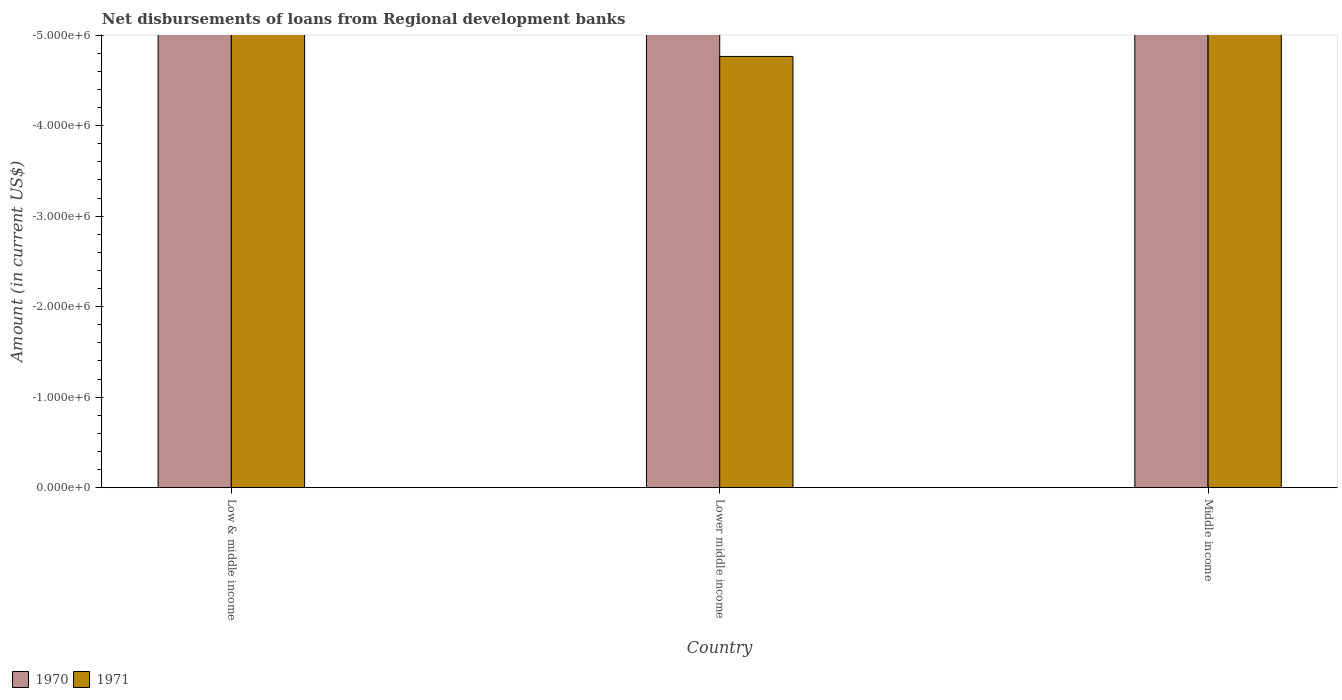How many different coloured bars are there?
Provide a short and direct response. 0. Are the number of bars per tick equal to the number of legend labels?
Provide a short and direct response. No. Are the number of bars on each tick of the X-axis equal?
Offer a very short reply. Yes. How many bars are there on the 2nd tick from the right?
Keep it short and to the point. 0. In how many cases, is the number of bars for a given country not equal to the number of legend labels?
Provide a short and direct response. 3. What is the amount of disbursements of loans from regional development banks in 1971 in Lower middle income?
Your answer should be compact. 0. What is the average amount of disbursements of loans from regional development banks in 1970 per country?
Give a very brief answer. 0. How many countries are there in the graph?
Provide a short and direct response. 3. Does the graph contain any zero values?
Provide a short and direct response. Yes. Does the graph contain grids?
Ensure brevity in your answer.  No. How many legend labels are there?
Ensure brevity in your answer.  2. What is the title of the graph?
Your answer should be very brief. Net disbursements of loans from Regional development banks. Does "2007" appear as one of the legend labels in the graph?
Offer a terse response. No. What is the label or title of the X-axis?
Your answer should be compact. Country. What is the label or title of the Y-axis?
Ensure brevity in your answer.  Amount (in current US$). What is the Amount (in current US$) in 1971 in Low & middle income?
Provide a succinct answer. 0. What is the Amount (in current US$) of 1970 in Lower middle income?
Your answer should be compact. 0. What is the average Amount (in current US$) in 1970 per country?
Keep it short and to the point. 0. What is the average Amount (in current US$) of 1971 per country?
Offer a terse response. 0. 